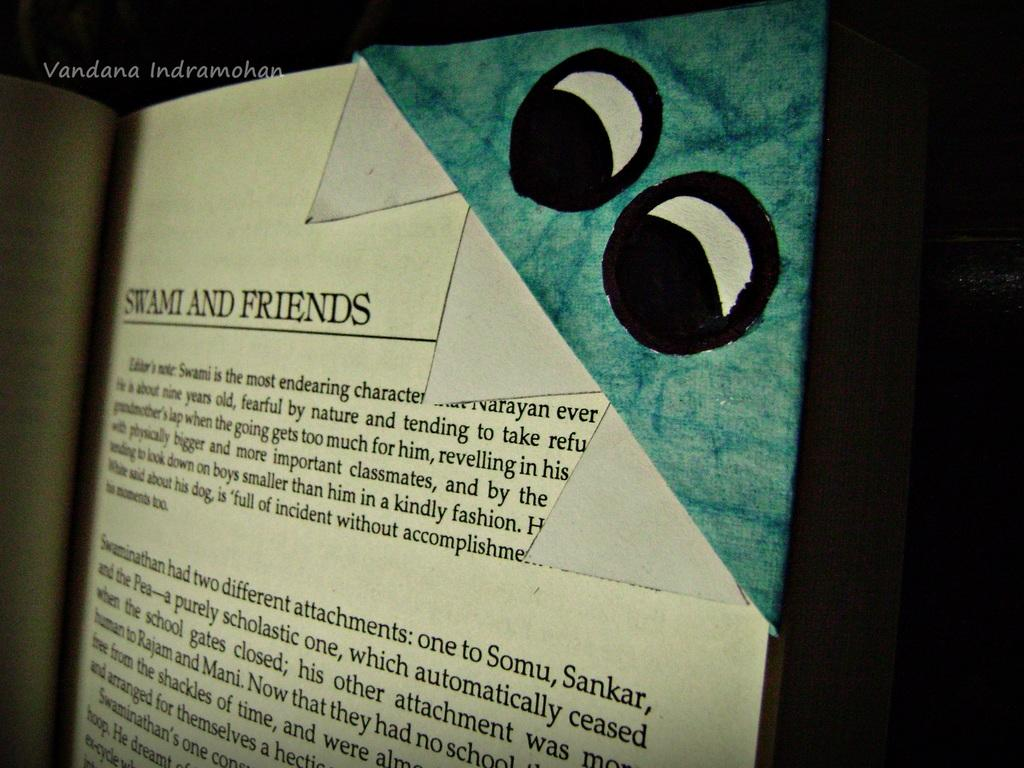<image>
Describe the image concisely. Page from a book that says "Swami and friends". 